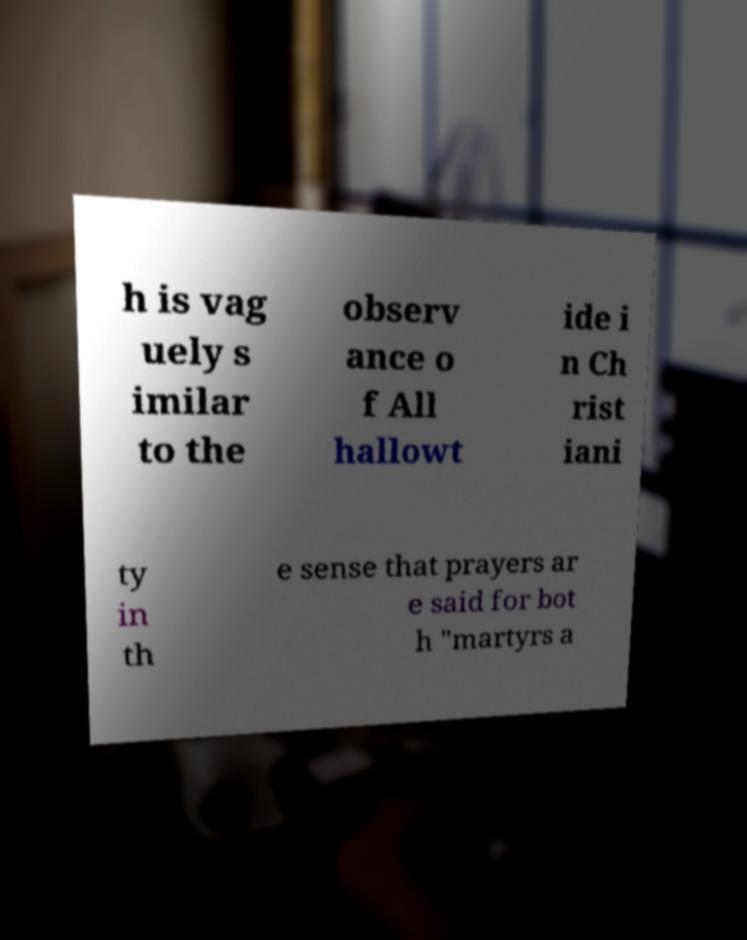I need the written content from this picture converted into text. Can you do that? h is vag uely s imilar to the observ ance o f All hallowt ide i n Ch rist iani ty in th e sense that prayers ar e said for bot h "martyrs a 